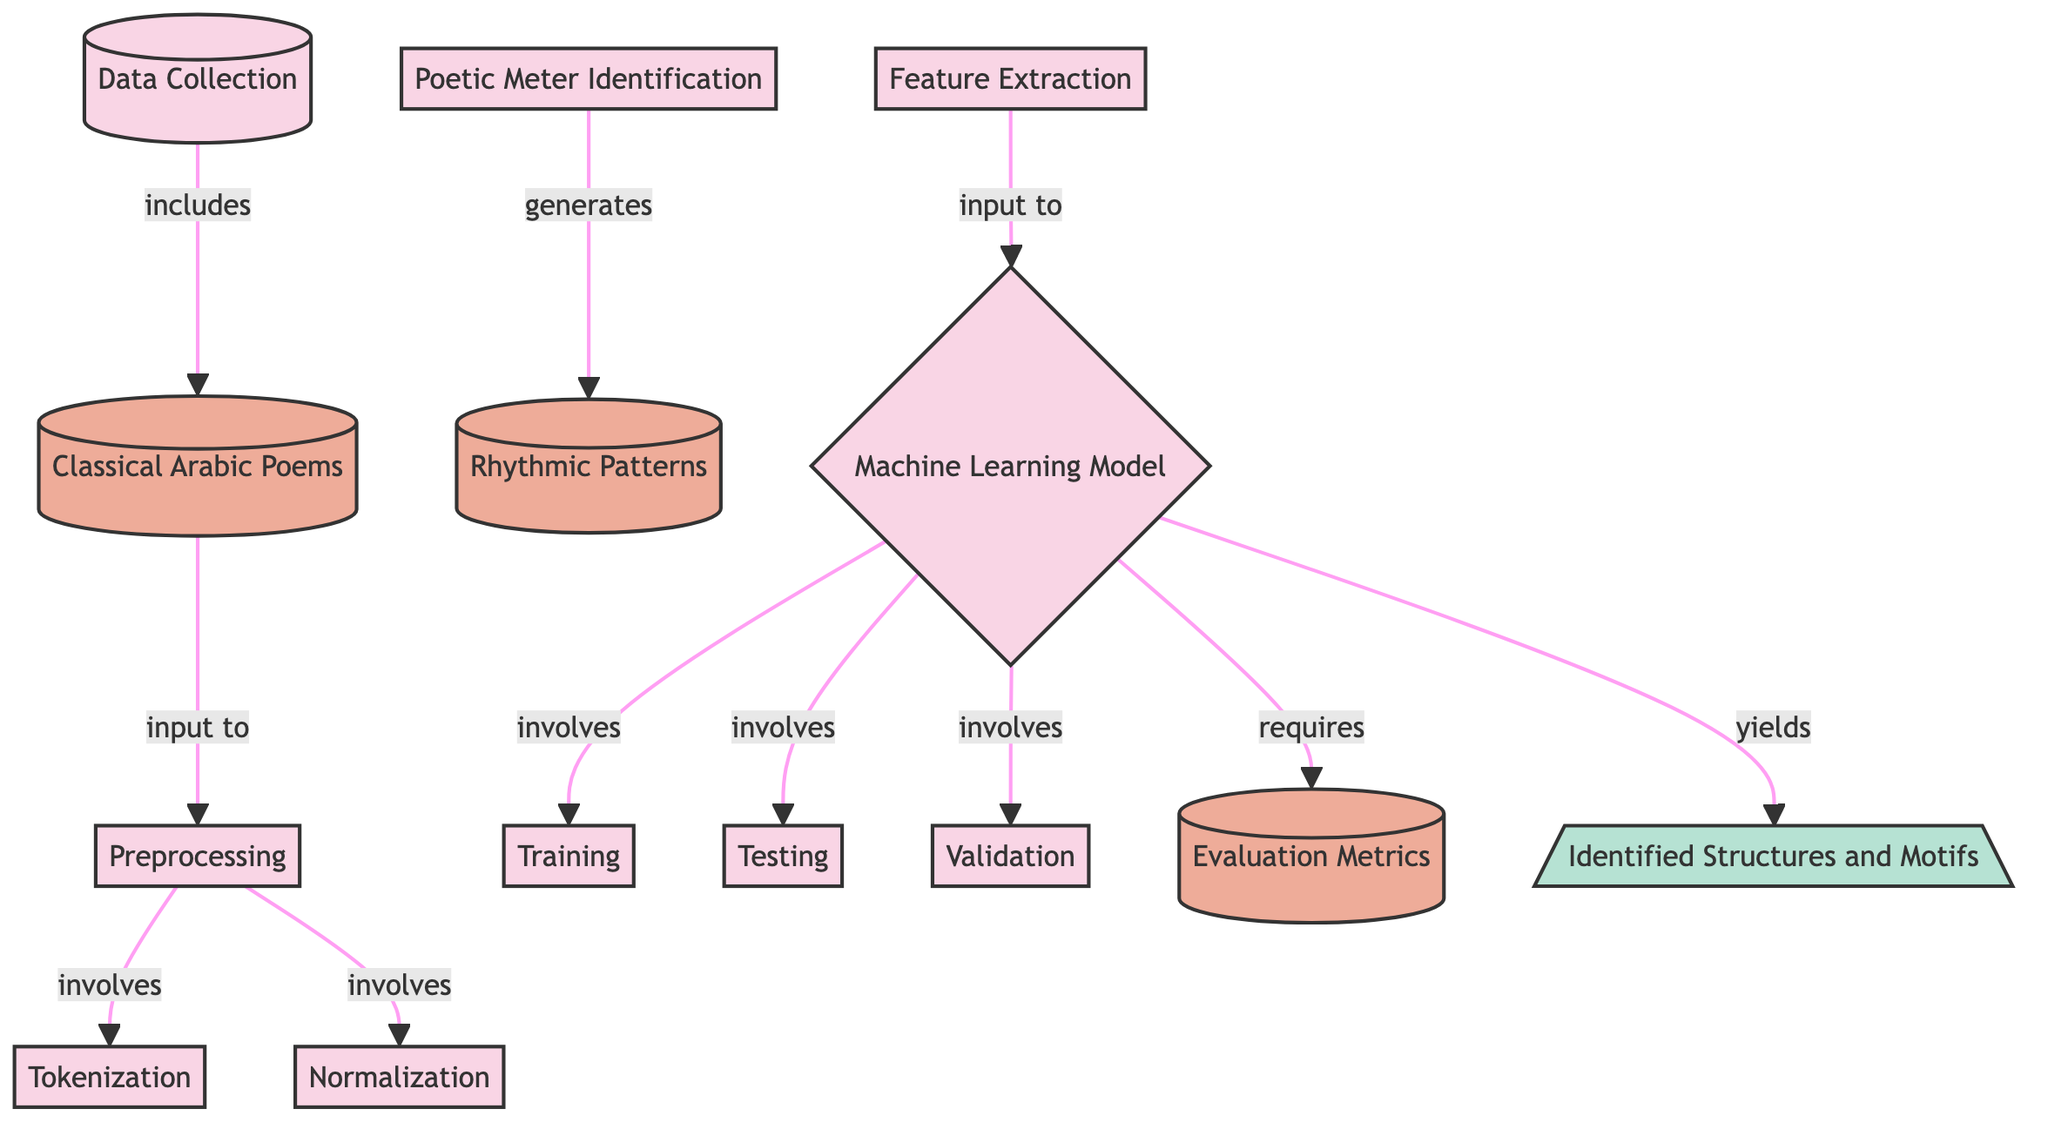What's the first step in the diagram? The first step in the diagram is "Data Collection," which is represented as the starting node that initiates the process.
Answer: Data Collection How many preprocessing tasks are listed in the diagram? There are three preprocessing tasks: "Tokenization," "Normalization," and "Poetic Meter Identification." These are indicated as separate nodes under the "Preprocessing" node.
Answer: Three What type of data is input into the preprocessing step? The data input into the preprocessing step is "Classical Arabic Poems," which is specified right before the preprocessing tasks begin.
Answer: Classical Arabic Poems What is the output of the machine learning model? The output of the machine learning model is "Identified Structures and Motifs," which is indicated as the final result of the process.
Answer: Identified Structures and Motifs Which process generates rhythmic patterns? The process that generates rhythmic patterns is "Poetic Meter Identification," as illustrated by the arrow pointing from that node to "Rhythmic Patterns."
Answer: Poetic Meter Identification What is the role of evaluation metrics in the diagram? The evaluation metrics serve as a requirement for the machine learning model, ensuring that the model's performance is assessed against specific criteria.
Answer: Requirement What relationship exists between feature extraction and the machine learning model? Feature extraction is an input to the machine learning model, meaning the features it extracts are necessary for the model to function and learn effectively.
Answer: Input How many testing phases are involved in the machine learning model? There are three testing phases involved: "Training," "Testing," and "Validation." These are shown as connected processes within the machine learning model node.
Answer: Three Which process leads to the identification of rhythmic patterns? The process that leads to the identification of rhythmic patterns is "Poetic Meter Identification," as it directly generates those patterns.
Answer: Poetic Meter Identification 